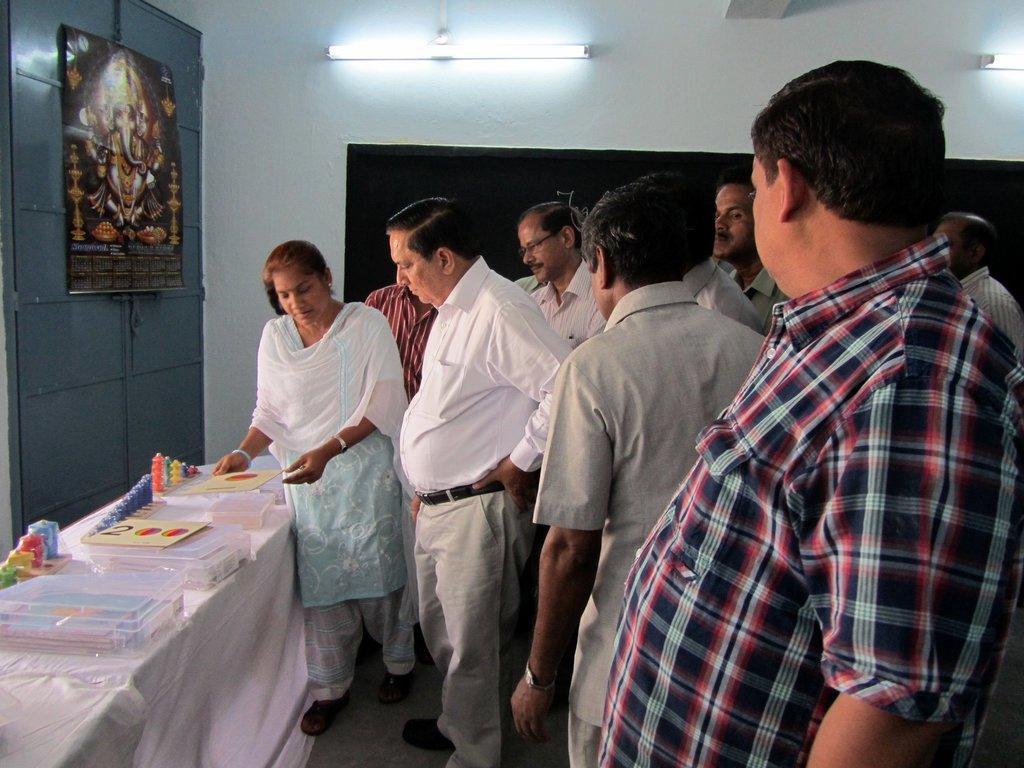Describe this image in one or two sentences. In this image we can see the people standing on the floor. We can also see a table which is covered with the cloth and on the table we can see the boxes, cards and also some other objects. We can see the wall, lights, a calendar with an idol hanged to the door. 